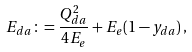Convert formula to latex. <formula><loc_0><loc_0><loc_500><loc_500>E _ { d a } \colon = \frac { Q _ { d a } ^ { 2 } } { 4 E _ { e } } + E _ { e } ( 1 - y _ { d a } ) \, ,</formula> 